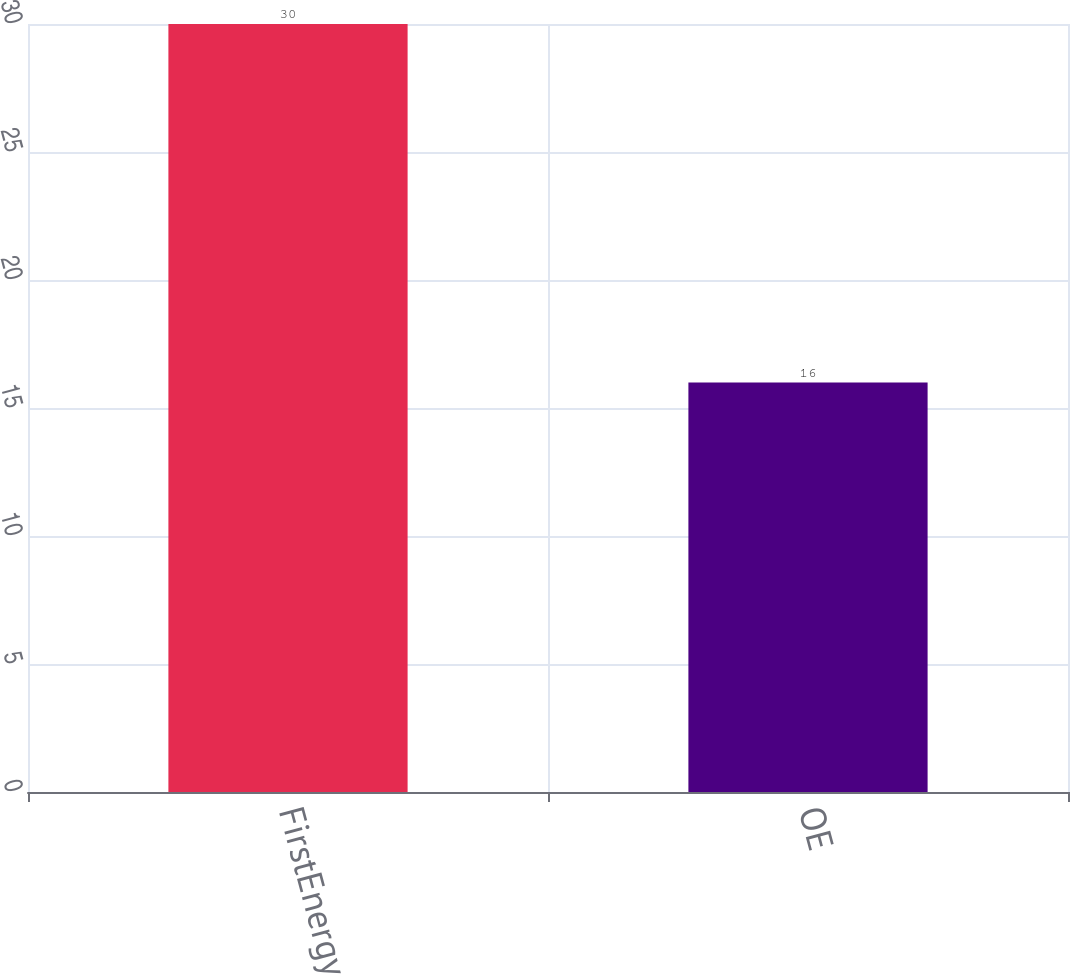<chart> <loc_0><loc_0><loc_500><loc_500><bar_chart><fcel>FirstEnergy<fcel>OE<nl><fcel>30<fcel>16<nl></chart> 